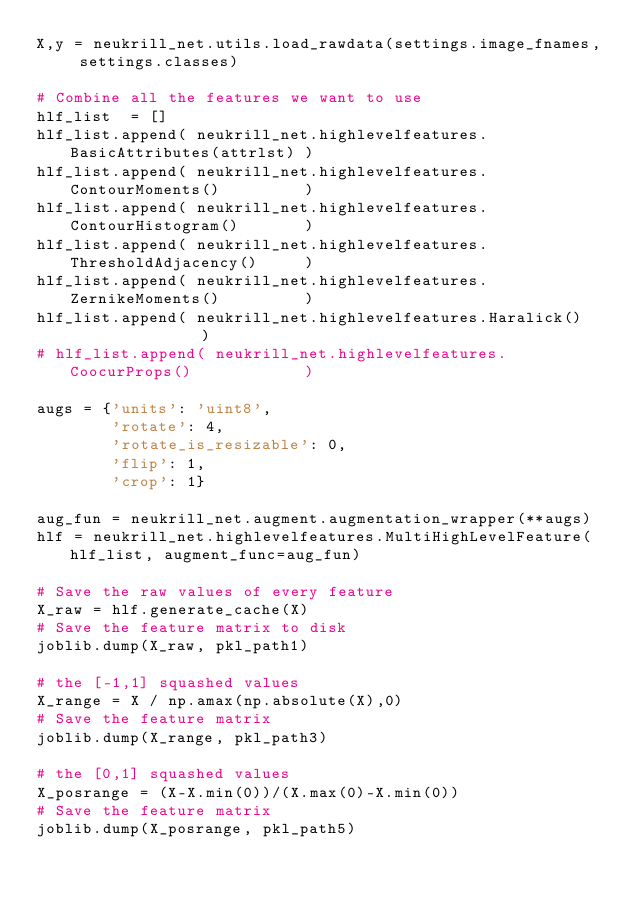<code> <loc_0><loc_0><loc_500><loc_500><_Python_>X,y = neukrill_net.utils.load_rawdata(settings.image_fnames, settings.classes)

# Combine all the features we want to use
hlf_list  = []
hlf_list.append( neukrill_net.highlevelfeatures.BasicAttributes(attrlst) )
hlf_list.append( neukrill_net.highlevelfeatures.ContourMoments()         )
hlf_list.append( neukrill_net.highlevelfeatures.ContourHistogram()       )
hlf_list.append( neukrill_net.highlevelfeatures.ThresholdAdjacency()     )
hlf_list.append( neukrill_net.highlevelfeatures.ZernikeMoments()         )
hlf_list.append( neukrill_net.highlevelfeatures.Haralick()               )
# hlf_list.append( neukrill_net.highlevelfeatures.CoocurProps()            )

augs = {'units': 'uint8',
        'rotate': 4,
        'rotate_is_resizable': 0,
        'flip': 1,
        'crop': 1}

aug_fun = neukrill_net.augment.augmentation_wrapper(**augs)
hlf = neukrill_net.highlevelfeatures.MultiHighLevelFeature(hlf_list, augment_func=aug_fun)

# Save the raw values of every feature
X_raw = hlf.generate_cache(X)
# Save the feature matrix to disk
joblib.dump(X_raw, pkl_path1)

# the [-1,1] squashed values
X_range = X / np.amax(np.absolute(X),0)
# Save the feature matrix
joblib.dump(X_range, pkl_path3)

# the [0,1] squashed values
X_posrange = (X-X.min(0))/(X.max(0)-X.min(0))
# Save the feature matrix
joblib.dump(X_posrange, pkl_path5)

</code> 